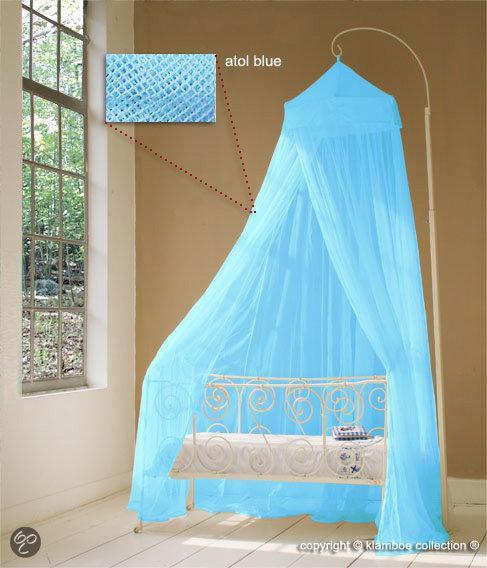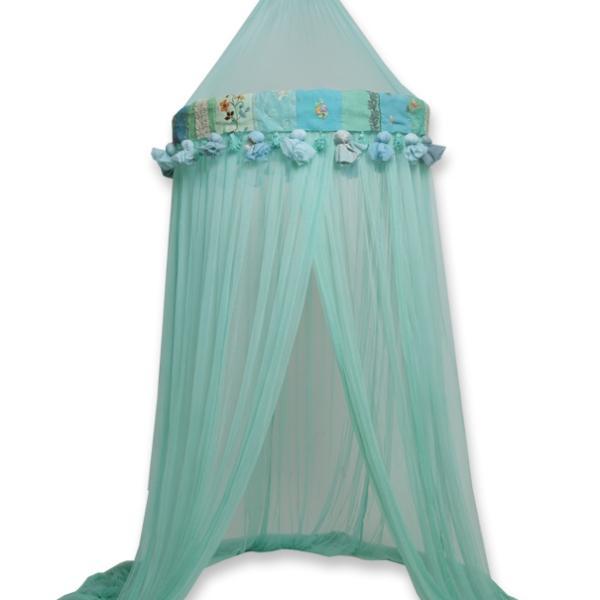The first image is the image on the left, the second image is the image on the right. Assess this claim about the two images: "The left and right image contains the same number of blue canopies.". Correct or not? Answer yes or no. No. The first image is the image on the left, the second image is the image on the right. Considering the images on both sides, is "An image shows a suspended blue canopy that does not cover the foot of a bed with a bold print bedspread." valid? Answer yes or no. No. 